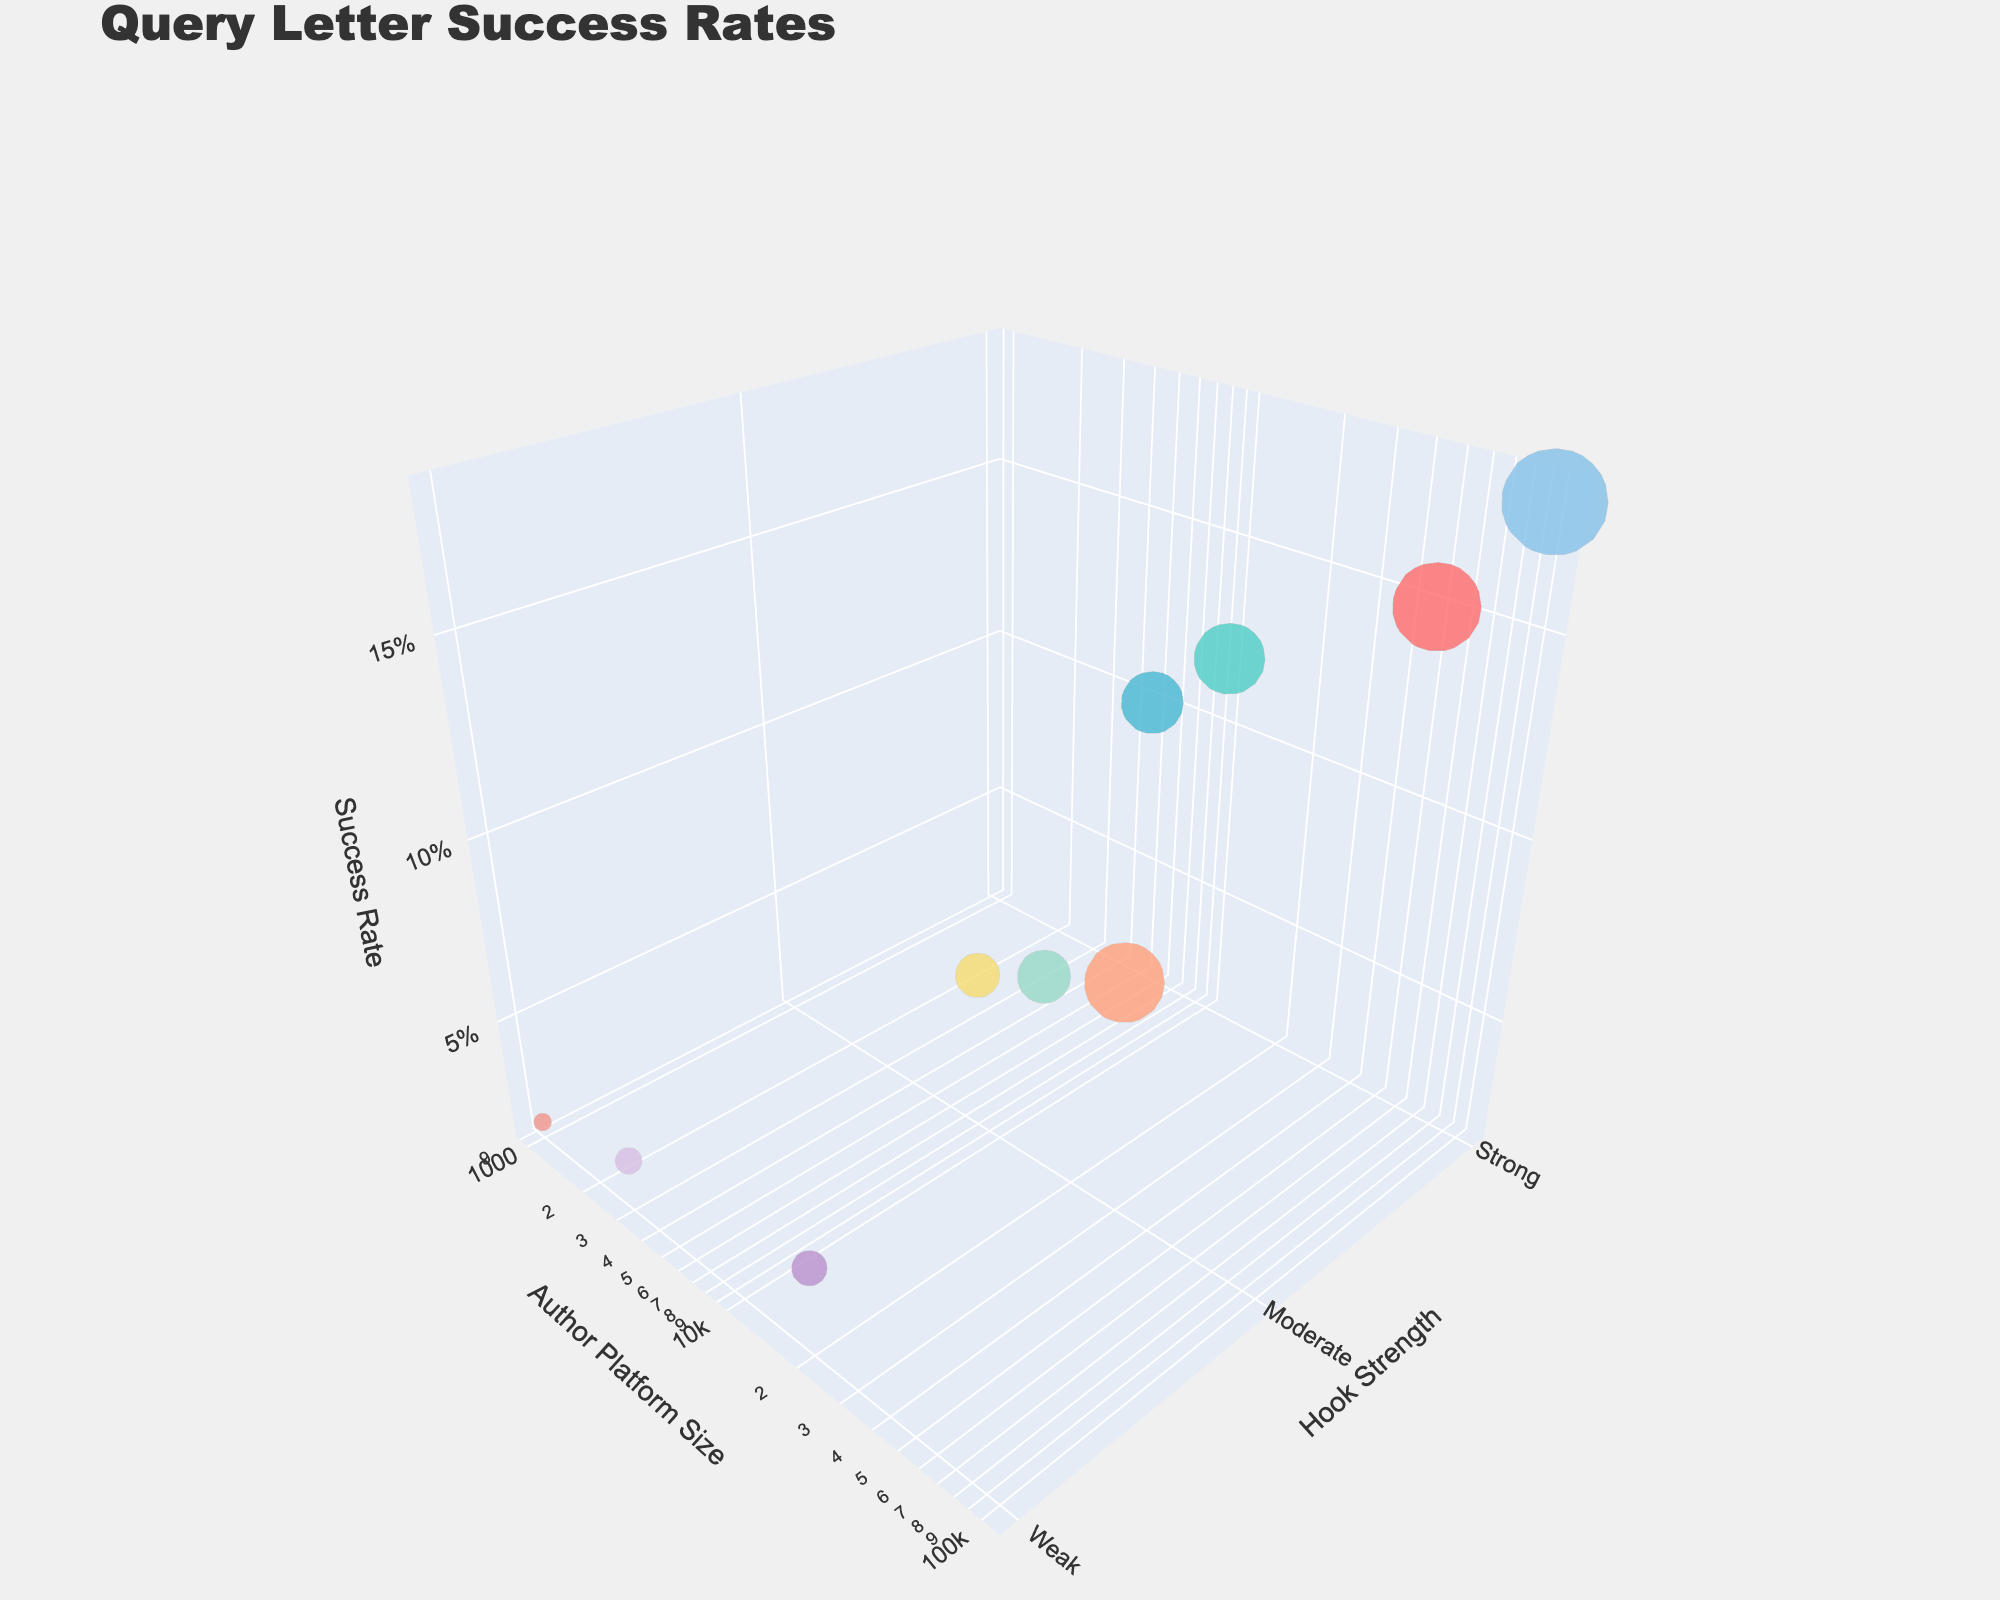How many data points are there in the figure? Count each distinct bubble representing a data point in the chart. There are 10 data points on the chart.
Answer: 10 What is the title of the figure? The title is usually positioned prominently at the top of the chart. In this figure, it is "Query Letter Success Rates".
Answer: Query Letter Success Rates Which manuscript genre has the highest success rate? Locate the point that has the highest 'Success Rate' value on the z-axis. The genre labeled at this point is "Non-Fiction".
Answer: Non-Fiction Which hook strength category has entries for the lowest author platform size? Find the lowest y-axis value for 'Author Platform Size' and check the 'Hook Strength' category for the corresponding data point, which is "Weak".
Answer: Weak What is the success rate for the Mystery genre with a strong hook? Find the data point associated with the Mystery genre and a strong hook, then check its z-axis value. The success rate for Mystery with a strong hook is 12%.
Answer: 12% How many manuscript genres fall under the 'Moderate' hook strength category? Identify and count all data points that have 'Moderate' as their hook strength. There are three genres: Fantasy, Thriller, and Historical Fiction.
Answer: 3 Which manuscript genre has the least number of submissions? Identify the point with the smallest bubble size on the chart, representing the number of submissions. It corresponds to "Horror".
Answer: Horror What is the relationship between hook strength and success rate? Analyze the z-axis (Success Rate) trends as the x-axis (Hook Strength) values change from 'Weak' to 'Strong'. Success rates generally increase with stronger hooks.
Answer: Success rates increase with stronger hooks Compare the success rates of manuscripts with strong hooks versus weak hooks. Identify success rates for all strong hook manuscripts and average them, do the same for weak hook manuscripts. Average success rate for strong hooks (0.15+0.12+0.10+0.18)/4 = 0.1375; for weak hooks (0.04+0.03+0.02)/3 = 0.03.
Answer: Strong hooks have a higher average success rate (0.1375) than weak hooks (0.03) What is the success rate for queries in the ‘Romance’ genre with strong hook strength? Locate the Romance genre point where hook strength is "Strong" and read the 'Success Rate' value on the z-axis.
Answer: 15% 